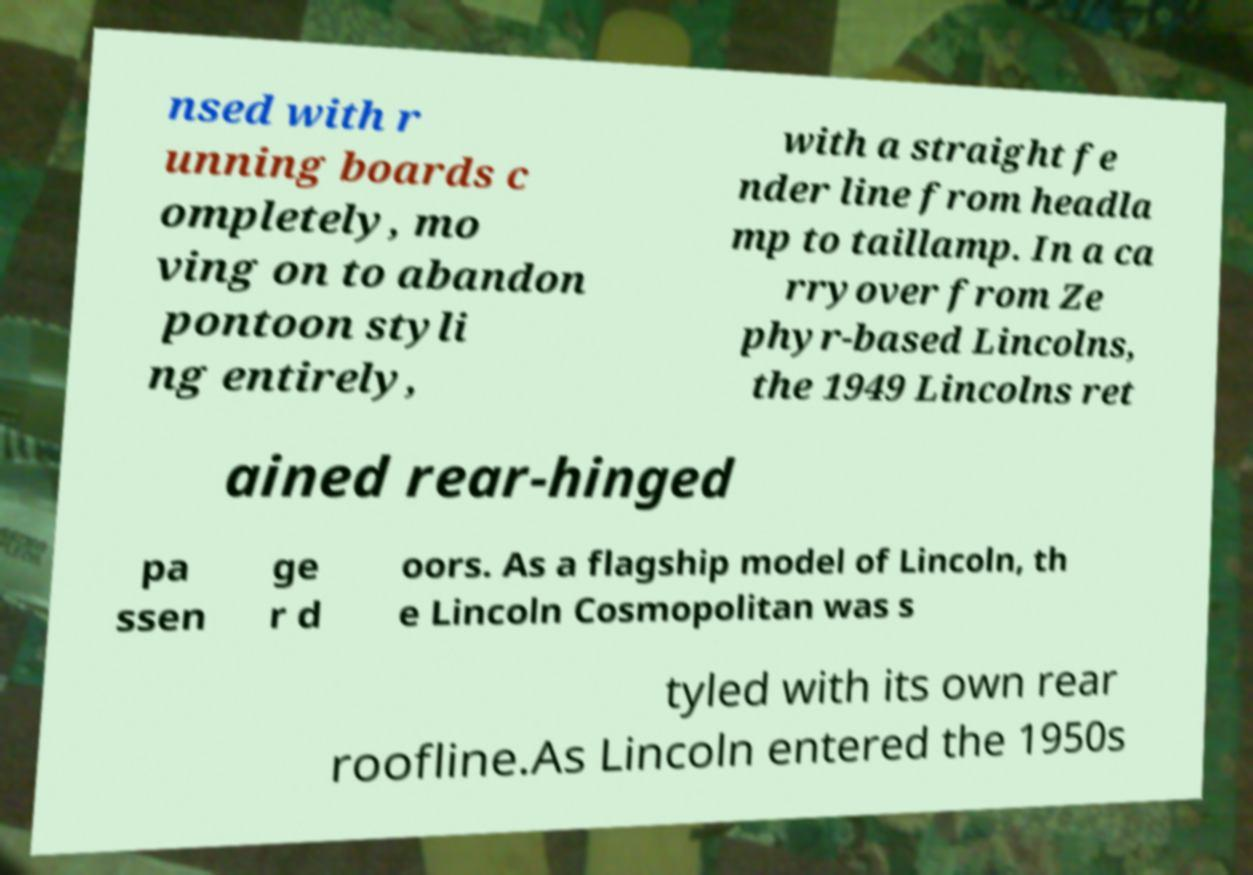For documentation purposes, I need the text within this image transcribed. Could you provide that? nsed with r unning boards c ompletely, mo ving on to abandon pontoon styli ng entirely, with a straight fe nder line from headla mp to taillamp. In a ca rryover from Ze phyr-based Lincolns, the 1949 Lincolns ret ained rear-hinged pa ssen ge r d oors. As a flagship model of Lincoln, th e Lincoln Cosmopolitan was s tyled with its own rear roofline.As Lincoln entered the 1950s 